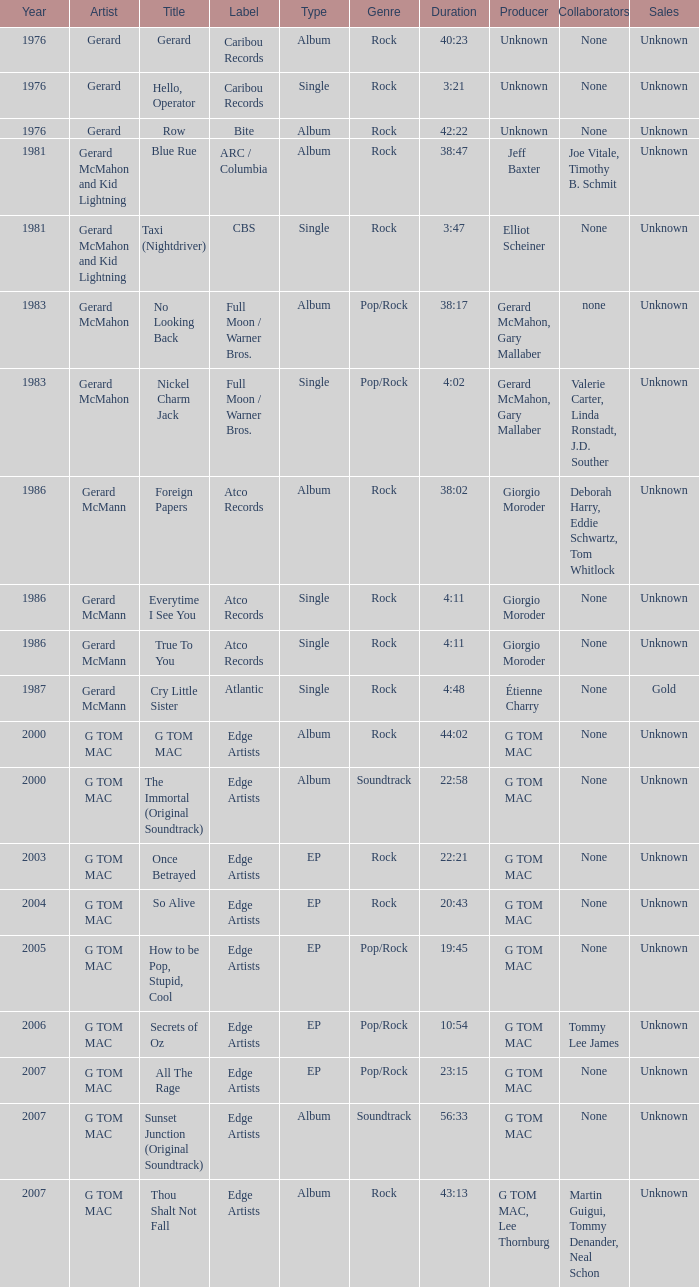Which Title has a Type of album and a Year larger than 1986? G TOM MAC, The Immortal (Original Soundtrack), Sunset Junction (Original Soundtrack), Thou Shalt Not Fall. 